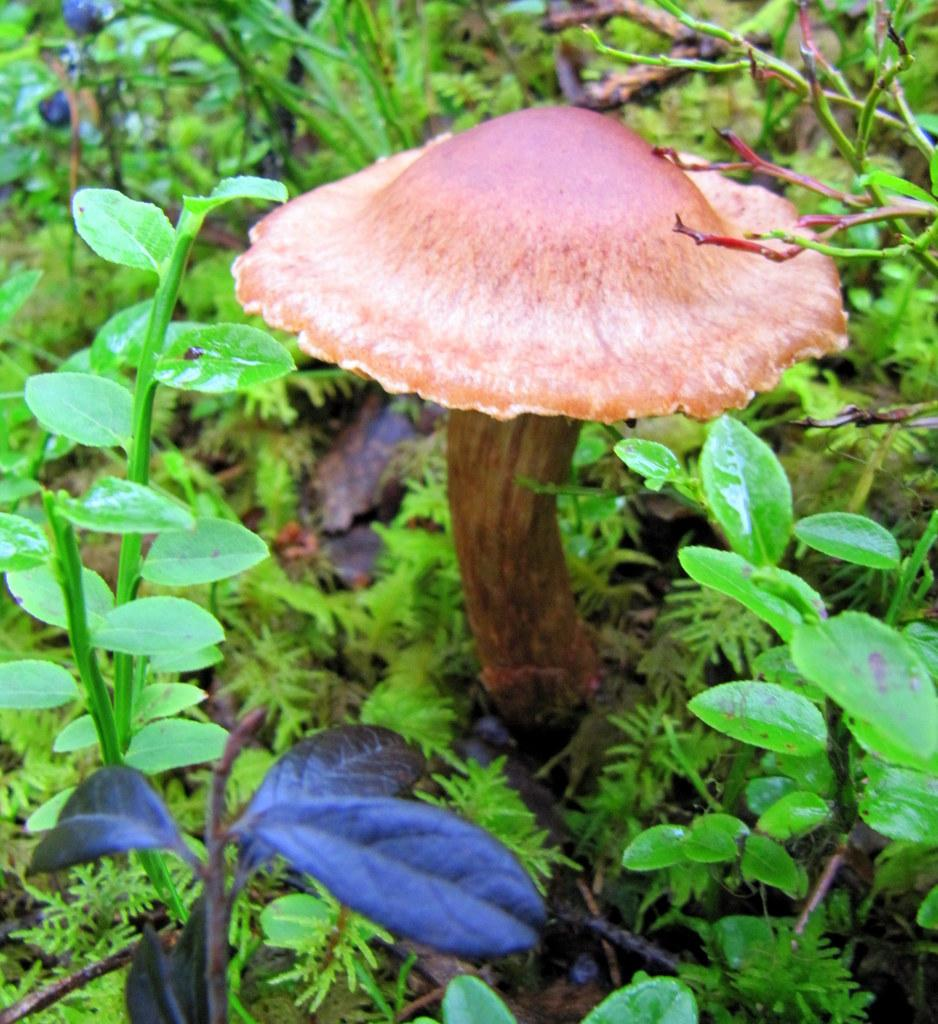What type of fungus can be seen in the image? There is a mushroom in the image. What other types of vegetation are present in the image? There are plants in the image. What type of rail can be seen in the image? There is no rail present in the image; it only features a mushroom and plants. How does the butter enhance the appearance of the mushroom in the image? There is no butter present in the image, so it cannot enhance the appearance of the mushroom. 